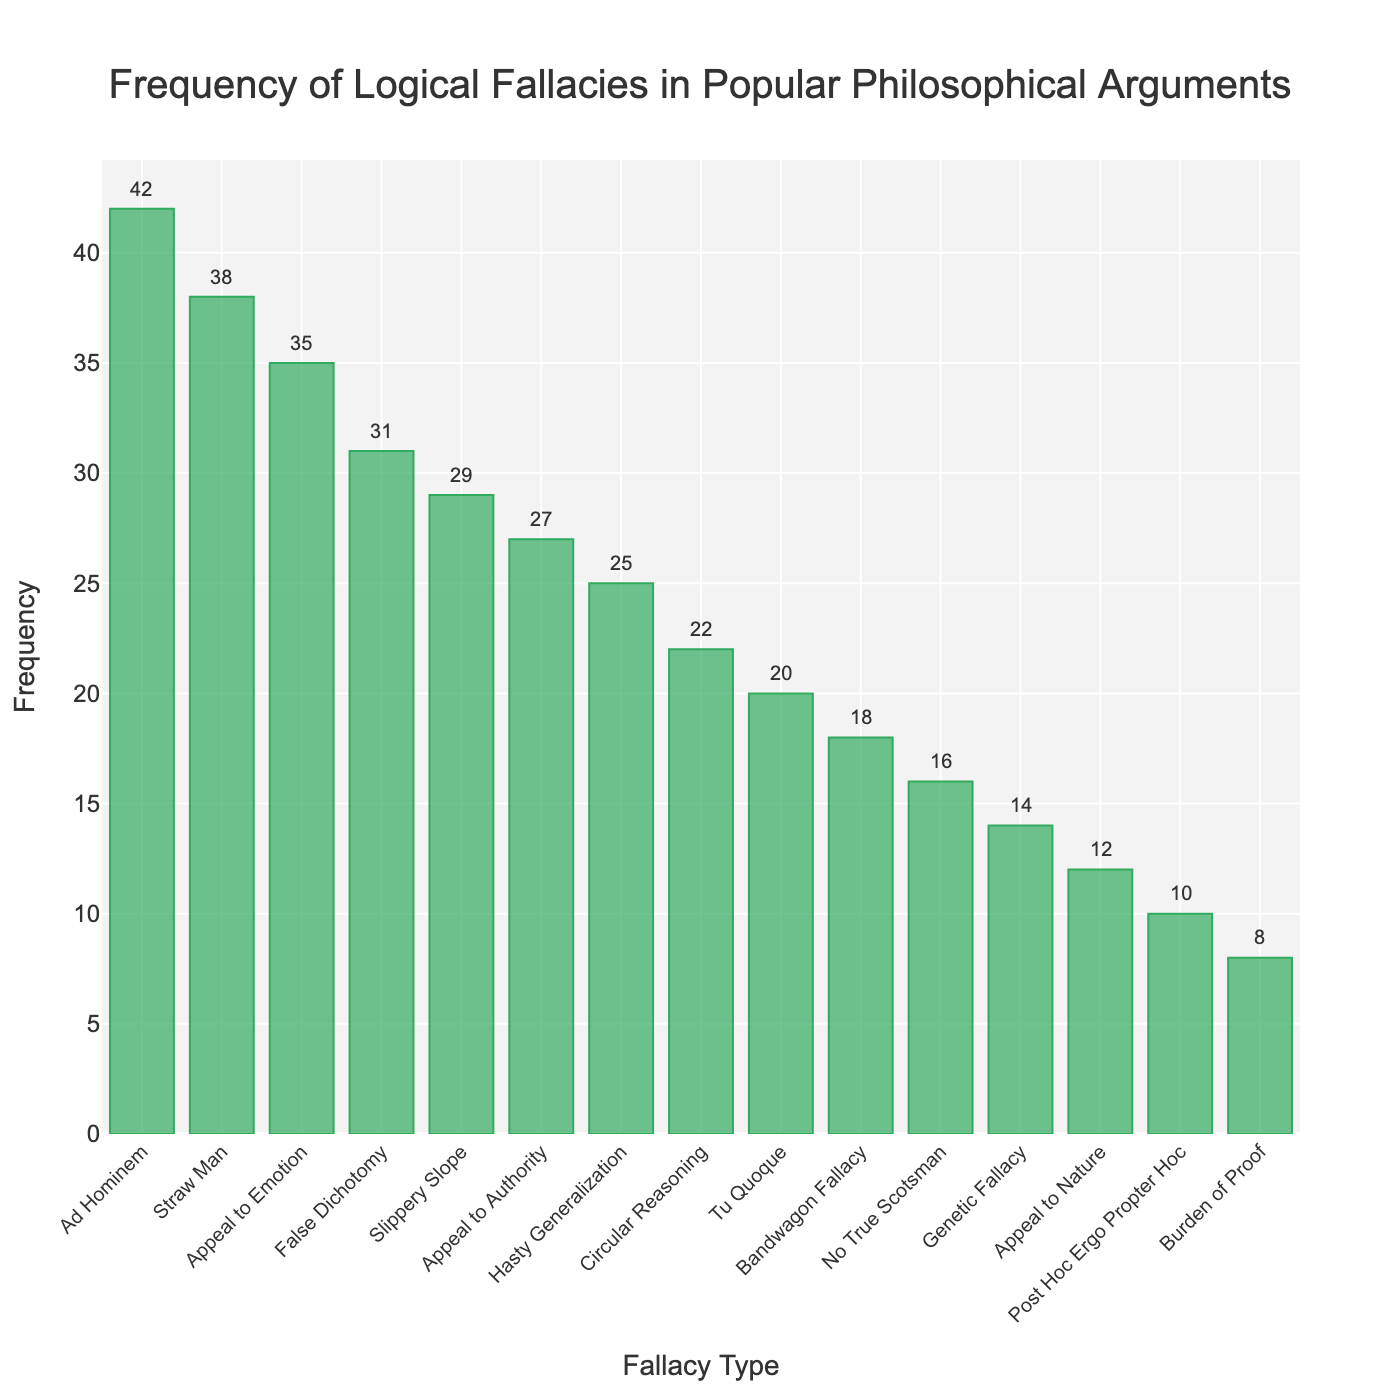Which logical fallacy appears most frequently in popular philosophical arguments? The bar at the far left has the tallest height, labeled "Ad Hominem" with a frequency of 42.
Answer: Ad Hominem Which logical fallacy is the least frequent in the data? The bar at the far right has the shortest height, labeled "Burden of Proof" with a frequency of 8.
Answer: Burden of Proof How many more times does the "Ad Hominem" fallacy appear compared to the "Burden of Proof" fallacy? The frequency of "Ad Hominem" is 42, and "Burden of Proof" is 8. The difference is 42 - 8 = 34.
Answer: 34 Which fallacies have a frequency equal to or above 30? Looking at the heights of the bars, "Ad Hominem", "Straw Man", "Appeal to Emotion", and "False Dichotomy" have frequencies of 42, 38, 35, and 31, respectively.
Answer: Ad Hominem, Straw Man, Appeal to Emotion, False Dichotomy What is the combined frequency of "Tu Quoque" and "Bandwagon Fallacy"? The frequency of "Tu Quoque" is 20, and "Bandwagon Fallacy" is 18. The combined frequency is 20 + 18 = 38.
Answer: 38 What percentage of the total frequency does "Ad Hominem" represent? Sum of all frequencies is 367. The frequency of "Ad Hominem" is 42. The percentage is (42/367) * 100 = approximately 11.45%.
Answer: 11.45% Which logical fallacy has a frequency exactly halfway between "Straw Man" and "Hasty Generalization"? The frequency of "Straw Man" is 38, and "Hasty Generalization" is 25. The average is (38 + 25) / 2 = 31.5. The closest fallacy to 31.5 is "False Dichotomy" with 31.
Answer: False Dichotomy Compare the frequency of "Slippery Slope" and "Circular Reasoning". Which is higher and by how much? The frequency of "Slippery Slope" is 29, and "Circular Reasoning" is 22. The difference is 29 - 22 = 7. "Slippery Slope" is higher by 7.
Answer: Slippery Slope by 7 What is the median frequency of all the fallacies? When the frequencies are sorted: 8, 10, 12, 14, 16, 18, 20, 22, 25, 27, 29, 31, 35, 38, 42. The middle value (8th value) is 22, which corresponds to "Circular Reasoning".
Answer: 22 How does the frequency of "No True Scotsman" compare to "Appeal to Nature"? The frequency of "No True Scotsman" is 16, while "Appeal to Nature" is 12. "No True Scotsman" is higher by 16 - 12 = 4.
Answer: No True Scotsman by 4 